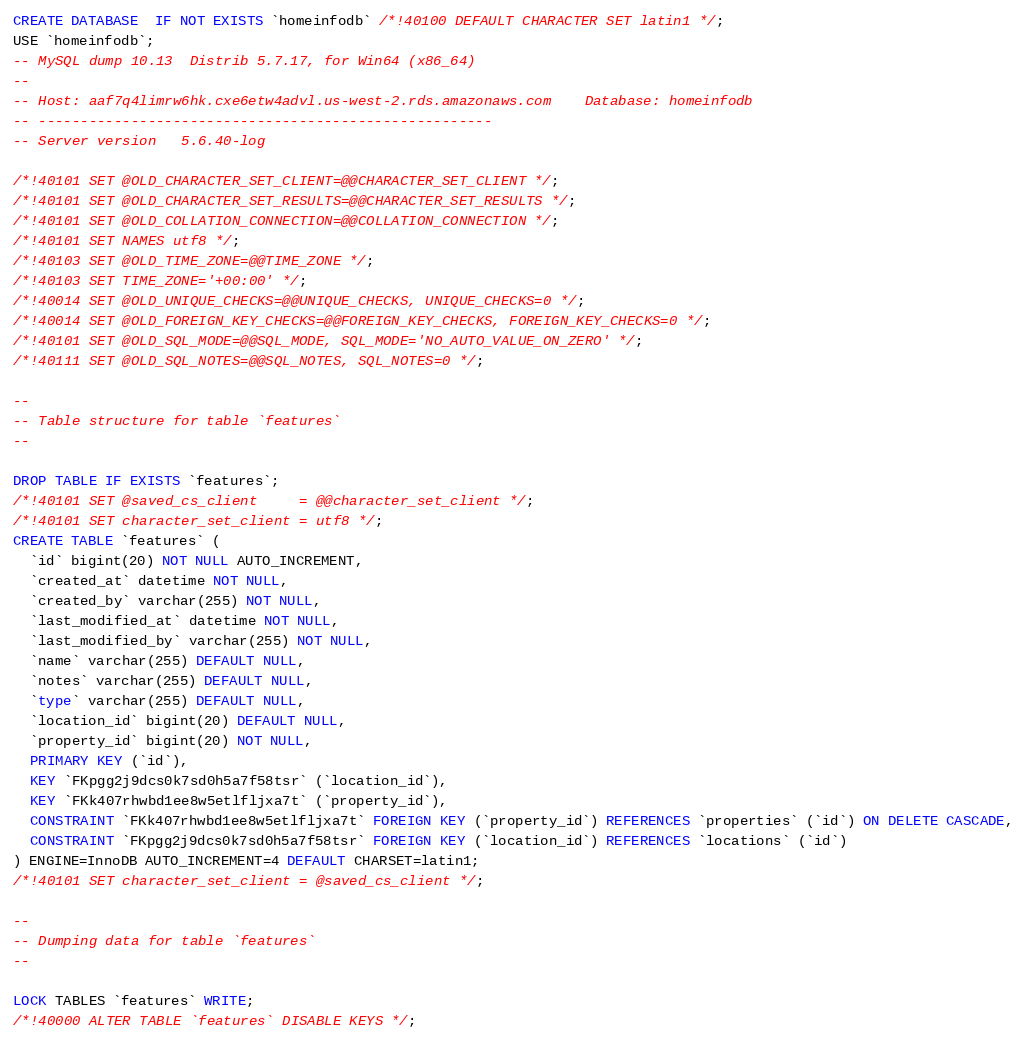Convert code to text. <code><loc_0><loc_0><loc_500><loc_500><_SQL_>CREATE DATABASE  IF NOT EXISTS `homeinfodb` /*!40100 DEFAULT CHARACTER SET latin1 */;
USE `homeinfodb`;
-- MySQL dump 10.13  Distrib 5.7.17, for Win64 (x86_64)
--
-- Host: aaf7q4limrw6hk.cxe6etw4advl.us-west-2.rds.amazonaws.com    Database: homeinfodb
-- ------------------------------------------------------
-- Server version	5.6.40-log

/*!40101 SET @OLD_CHARACTER_SET_CLIENT=@@CHARACTER_SET_CLIENT */;
/*!40101 SET @OLD_CHARACTER_SET_RESULTS=@@CHARACTER_SET_RESULTS */;
/*!40101 SET @OLD_COLLATION_CONNECTION=@@COLLATION_CONNECTION */;
/*!40101 SET NAMES utf8 */;
/*!40103 SET @OLD_TIME_ZONE=@@TIME_ZONE */;
/*!40103 SET TIME_ZONE='+00:00' */;
/*!40014 SET @OLD_UNIQUE_CHECKS=@@UNIQUE_CHECKS, UNIQUE_CHECKS=0 */;
/*!40014 SET @OLD_FOREIGN_KEY_CHECKS=@@FOREIGN_KEY_CHECKS, FOREIGN_KEY_CHECKS=0 */;
/*!40101 SET @OLD_SQL_MODE=@@SQL_MODE, SQL_MODE='NO_AUTO_VALUE_ON_ZERO' */;
/*!40111 SET @OLD_SQL_NOTES=@@SQL_NOTES, SQL_NOTES=0 */;

--
-- Table structure for table `features`
--

DROP TABLE IF EXISTS `features`;
/*!40101 SET @saved_cs_client     = @@character_set_client */;
/*!40101 SET character_set_client = utf8 */;
CREATE TABLE `features` (
  `id` bigint(20) NOT NULL AUTO_INCREMENT,
  `created_at` datetime NOT NULL,
  `created_by` varchar(255) NOT NULL,
  `last_modified_at` datetime NOT NULL,
  `last_modified_by` varchar(255) NOT NULL,
  `name` varchar(255) DEFAULT NULL,
  `notes` varchar(255) DEFAULT NULL,
  `type` varchar(255) DEFAULT NULL,
  `location_id` bigint(20) DEFAULT NULL,
  `property_id` bigint(20) NOT NULL,
  PRIMARY KEY (`id`),
  KEY `FKpgg2j9dcs0k7sd0h5a7f58tsr` (`location_id`),
  KEY `FKk407rhwbd1ee8w5etlfljxa7t` (`property_id`),
  CONSTRAINT `FKk407rhwbd1ee8w5etlfljxa7t` FOREIGN KEY (`property_id`) REFERENCES `properties` (`id`) ON DELETE CASCADE,
  CONSTRAINT `FKpgg2j9dcs0k7sd0h5a7f58tsr` FOREIGN KEY (`location_id`) REFERENCES `locations` (`id`)
) ENGINE=InnoDB AUTO_INCREMENT=4 DEFAULT CHARSET=latin1;
/*!40101 SET character_set_client = @saved_cs_client */;

--
-- Dumping data for table `features`
--

LOCK TABLES `features` WRITE;
/*!40000 ALTER TABLE `features` DISABLE KEYS */;</code> 